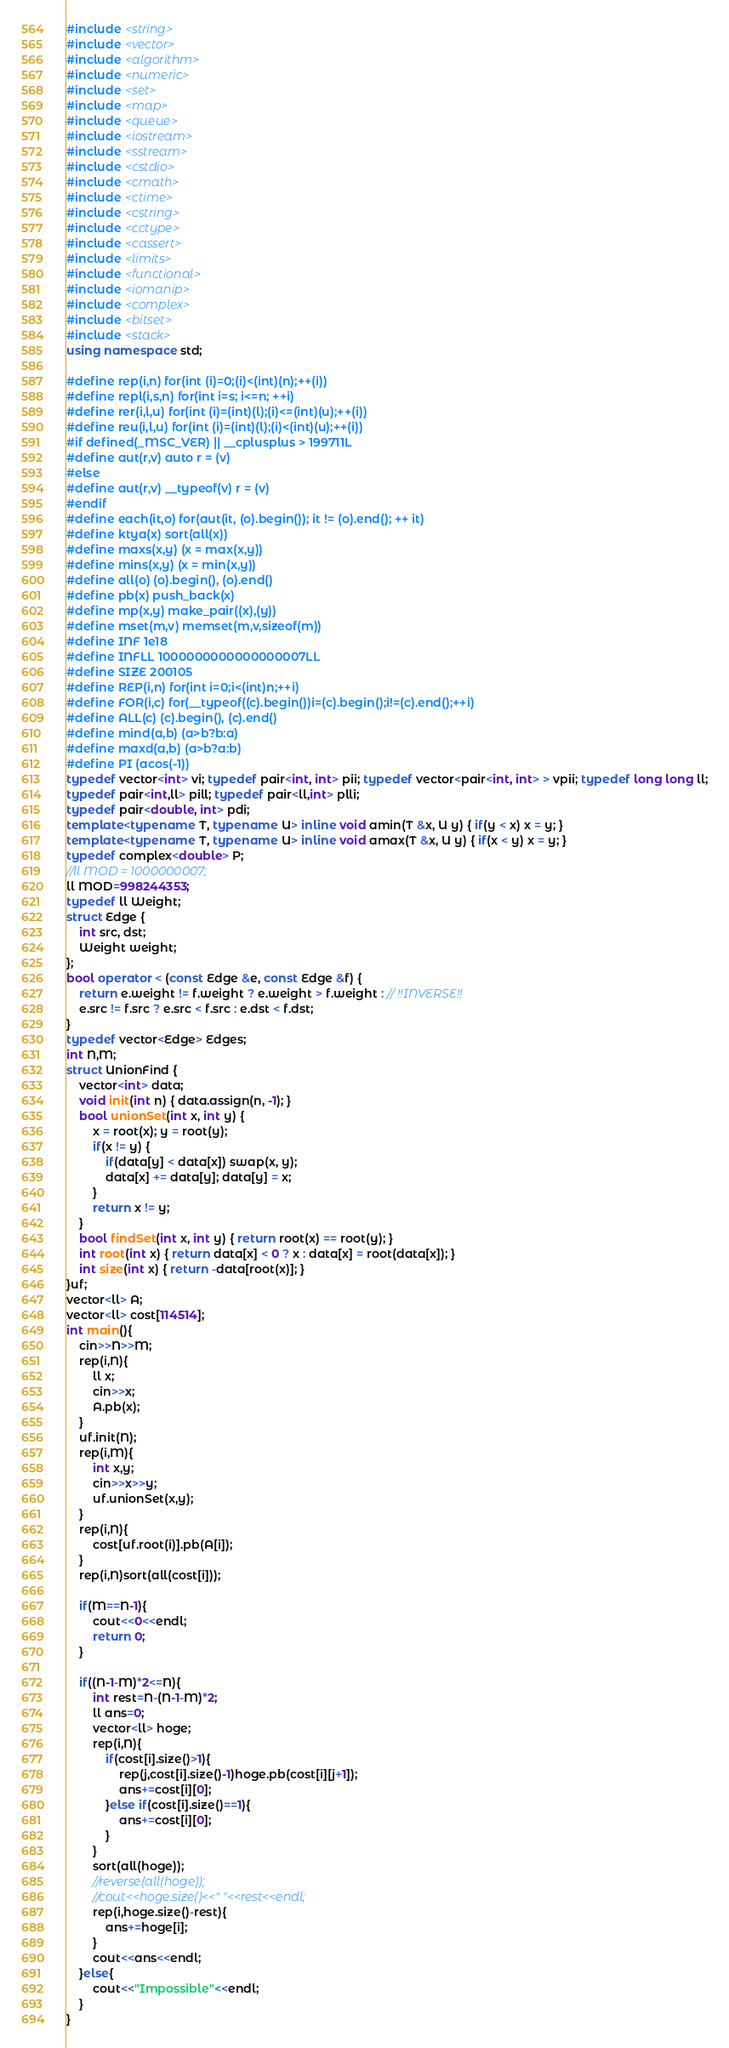Convert code to text. <code><loc_0><loc_0><loc_500><loc_500><_C++_>#include <string>
#include <vector>
#include <algorithm>
#include <numeric>
#include <set>
#include <map>
#include <queue>
#include <iostream>
#include <sstream>
#include <cstdio>
#include <cmath>
#include <ctime>
#include <cstring>
#include <cctype>
#include <cassert>
#include <limits>
#include <functional>
#include <iomanip>
#include <complex>
#include <bitset>
#include <stack>
using namespace std;
 
#define rep(i,n) for(int (i)=0;(i)<(int)(n);++(i))
#define repl(i,s,n) for(int i=s; i<=n; ++i)
#define rer(i,l,u) for(int (i)=(int)(l);(i)<=(int)(u);++(i))
#define reu(i,l,u) for(int (i)=(int)(l);(i)<(int)(u);++(i))
#if defined(_MSC_VER) || __cplusplus > 199711L
#define aut(r,v) auto r = (v)
#else
#define aut(r,v) __typeof(v) r = (v)
#endif
#define each(it,o) for(aut(it, (o).begin()); it != (o).end(); ++ it)
#define ktya(x) sort(all(x))
#define maxs(x,y) (x = max(x,y))
#define mins(x,y) (x = min(x,y))
#define all(o) (o).begin(), (o).end()
#define pb(x) push_back(x)
#define mp(x,y) make_pair((x),(y))
#define mset(m,v) memset(m,v,sizeof(m))
#define INF 1e18
#define INFLL 1000000000000000007LL
#define SIZE 200105
#define REP(i,n) for(int i=0;i<(int)n;++i)
#define FOR(i,c) for(__typeof((c).begin())i=(c).begin();i!=(c).end();++i)
#define ALL(c) (c).begin(), (c).end()
#define mind(a,b) (a>b?b:a)
#define maxd(a,b) (a>b?a:b)
#define PI (acos(-1))
typedef vector<int> vi; typedef pair<int, int> pii; typedef vector<pair<int, int> > vpii; typedef long long ll;
typedef pair<int,ll> pill; typedef pair<ll,int> plli; 
typedef pair<double, int> pdi;
template<typename T, typename U> inline void amin(T &x, U y) { if(y < x) x = y; }
template<typename T, typename U> inline void amax(T &x, U y) { if(x < y) x = y; }
typedef complex<double> P;
//ll MOD = 1000000007;
ll MOD=998244353;
typedef ll Weight;
struct Edge {
	int src, dst;
	Weight weight;
};
bool operator < (const Edge &e, const Edge &f) {
	return e.weight != f.weight ? e.weight > f.weight : // !!INVERSE!!
	e.src != f.src ? e.src < f.src : e.dst < f.dst;
}
typedef vector<Edge> Edges;
int N,M;
struct UnionFind {
	vector<int> data;
	void init(int n) { data.assign(n, -1); }
	bool unionSet(int x, int y) {
		x = root(x); y = root(y);
		if(x != y) {
			if(data[y] < data[x]) swap(x, y);
			data[x] += data[y]; data[y] = x;
		}
		return x != y;
	}
	bool findSet(int x, int y) { return root(x) == root(y); }
	int root(int x) { return data[x] < 0 ? x : data[x] = root(data[x]); }
	int size(int x) { return -data[root(x)]; }
}uf;
vector<ll> A;
vector<ll> cost[114514];
int main(){
	cin>>N>>M;
	rep(i,N){
		ll x;
		cin>>x;
		A.pb(x);
	}
	uf.init(N);
	rep(i,M){
		int x,y;
		cin>>x>>y;
		uf.unionSet(x,y);
	}
	rep(i,N){
		cost[uf.root(i)].pb(A[i]);
	}
	rep(i,N)sort(all(cost[i]));
	
	if(M==N-1){
		cout<<0<<endl;
		return 0;
	}
	
	if((N-1-M)*2<=N){
		int rest=N-(N-1-M)*2;
		ll ans=0;
		vector<ll> hoge;
		rep(i,N){
			if(cost[i].size()>1){
				rep(j,cost[i].size()-1)hoge.pb(cost[i][j+1]);
				ans+=cost[i][0];
			}else if(cost[i].size()==1){
				ans+=cost[i][0];
			}
		}
		sort(all(hoge));
		//reverse(all(hoge));
		//cout<<hoge.size()<<" "<<rest<<endl;
		rep(i,hoge.size()-rest){
			ans+=hoge[i];
		}
		cout<<ans<<endl;
	}else{
		cout<<"Impossible"<<endl;
	}
}
</code> 